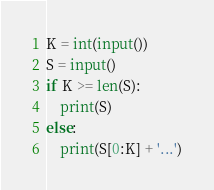Convert code to text. <code><loc_0><loc_0><loc_500><loc_500><_Python_>K = int(input())
S = input()
if K >= len(S):
    print(S)
else:
    print(S[0:K] + '...')</code> 